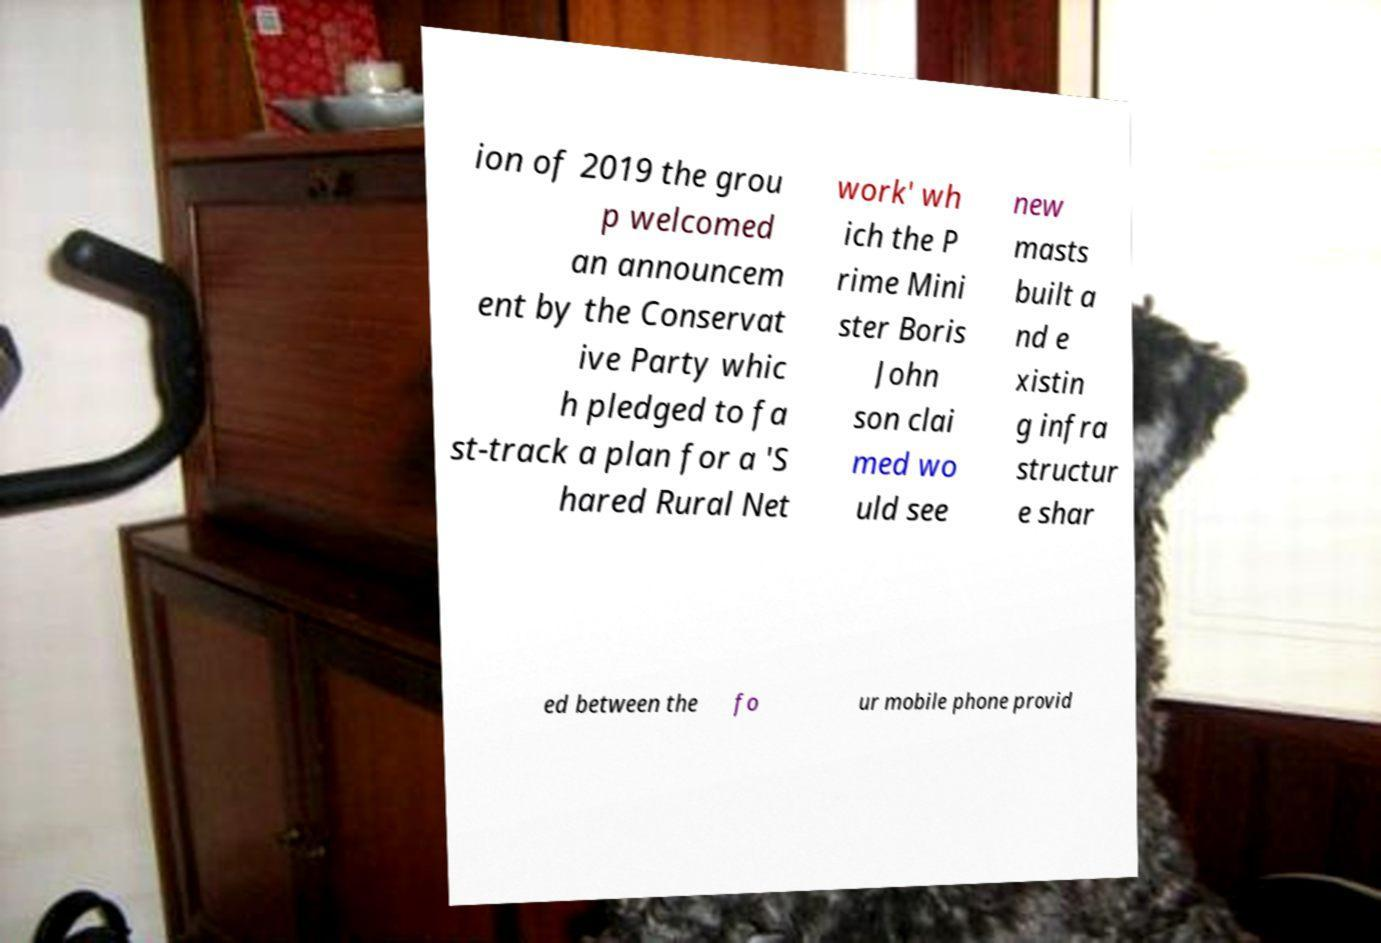What messages or text are displayed in this image? I need them in a readable, typed format. ion of 2019 the grou p welcomed an announcem ent by the Conservat ive Party whic h pledged to fa st-track a plan for a 'S hared Rural Net work' wh ich the P rime Mini ster Boris John son clai med wo uld see new masts built a nd e xistin g infra structur e shar ed between the fo ur mobile phone provid 